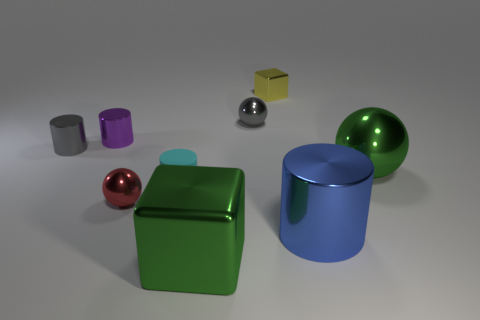Subtract all tiny metallic spheres. How many spheres are left? 1 Add 1 gray balls. How many objects exist? 10 Subtract 2 spheres. How many spheres are left? 1 Subtract all spheres. How many objects are left? 6 Subtract 0 cyan spheres. How many objects are left? 9 Subtract all gray spheres. Subtract all brown blocks. How many spheres are left? 2 Subtract all gray metallic things. Subtract all blue things. How many objects are left? 6 Add 1 metal cylinders. How many metal cylinders are left? 4 Add 6 tiny yellow metallic blocks. How many tiny yellow metallic blocks exist? 7 Subtract all green cubes. How many cubes are left? 1 